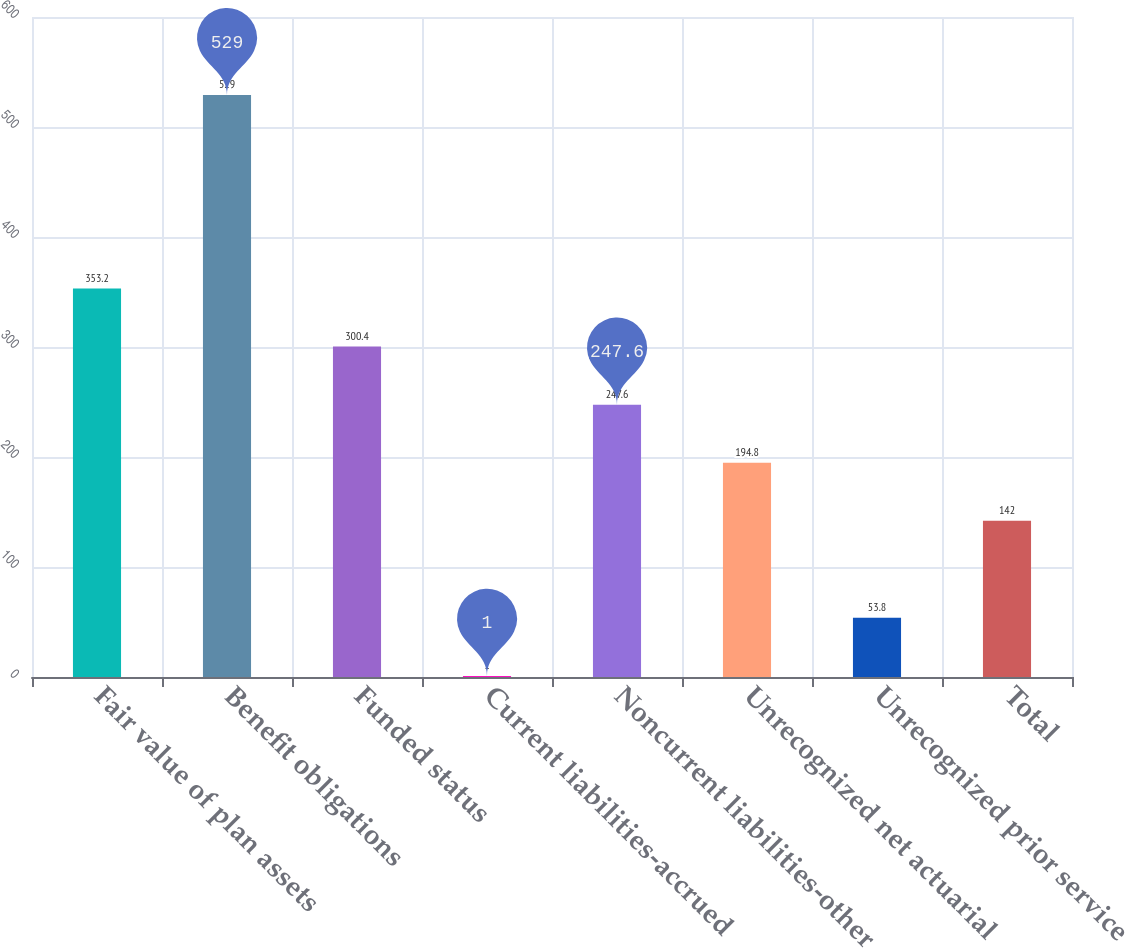Convert chart to OTSL. <chart><loc_0><loc_0><loc_500><loc_500><bar_chart><fcel>Fair value of plan assets<fcel>Benefit obligations<fcel>Funded status<fcel>Current liabilities-accrued<fcel>Noncurrent liabilities-other<fcel>Unrecognized net actuarial<fcel>Unrecognized prior service<fcel>Total<nl><fcel>353.2<fcel>529<fcel>300.4<fcel>1<fcel>247.6<fcel>194.8<fcel>53.8<fcel>142<nl></chart> 